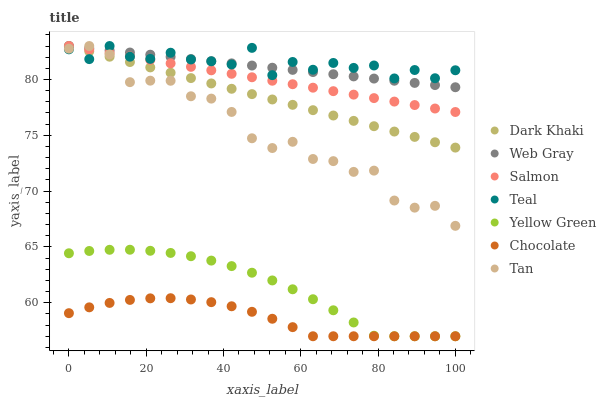Does Chocolate have the minimum area under the curve?
Answer yes or no. Yes. Does Teal have the maximum area under the curve?
Answer yes or no. Yes. Does Yellow Green have the minimum area under the curve?
Answer yes or no. No. Does Yellow Green have the maximum area under the curve?
Answer yes or no. No. Is Web Gray the smoothest?
Answer yes or no. Yes. Is Teal the roughest?
Answer yes or no. Yes. Is Yellow Green the smoothest?
Answer yes or no. No. Is Yellow Green the roughest?
Answer yes or no. No. Does Yellow Green have the lowest value?
Answer yes or no. Yes. Does Salmon have the lowest value?
Answer yes or no. No. Does Tan have the highest value?
Answer yes or no. Yes. Does Yellow Green have the highest value?
Answer yes or no. No. Is Yellow Green less than Tan?
Answer yes or no. Yes. Is Dark Khaki greater than Chocolate?
Answer yes or no. Yes. Does Salmon intersect Teal?
Answer yes or no. Yes. Is Salmon less than Teal?
Answer yes or no. No. Is Salmon greater than Teal?
Answer yes or no. No. Does Yellow Green intersect Tan?
Answer yes or no. No. 